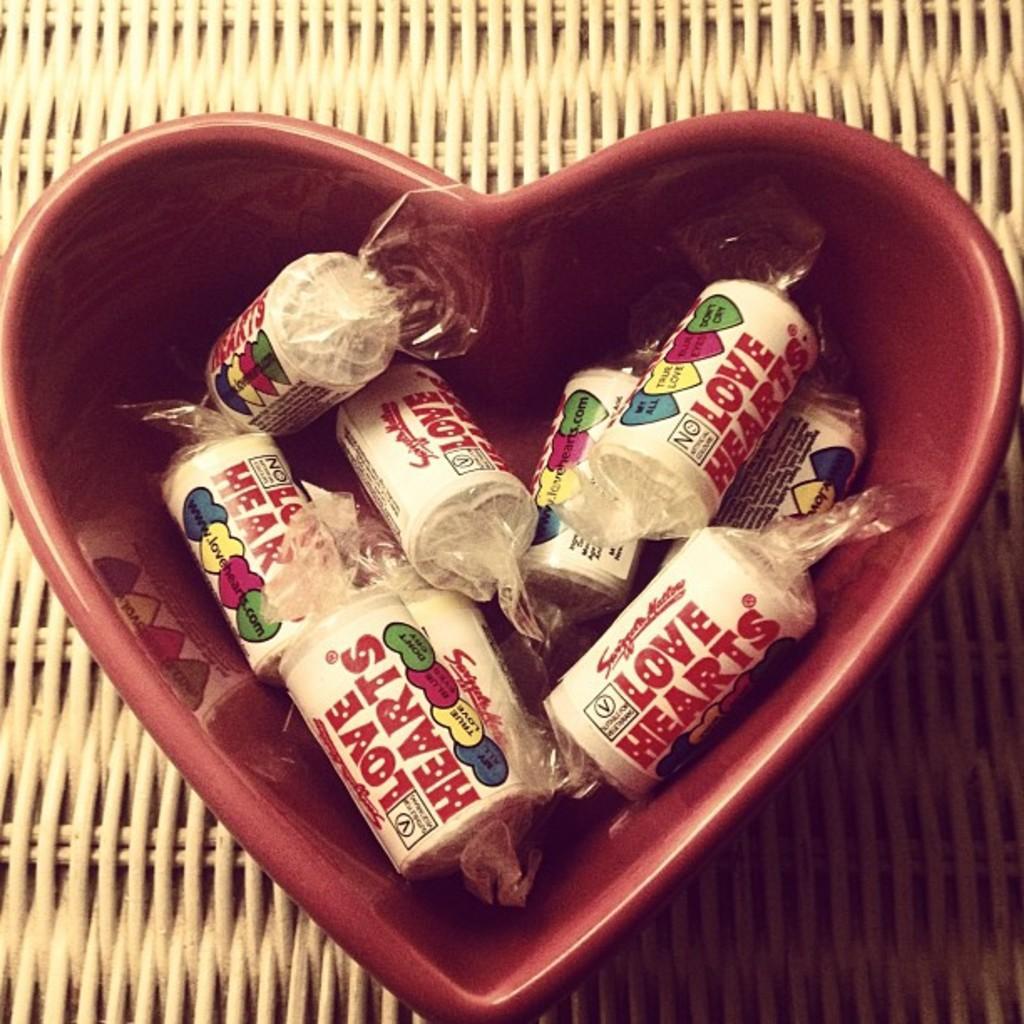Could you give a brief overview of what you see in this image? In this image there are some candies named love hearts are in the bowl which is in red color. 